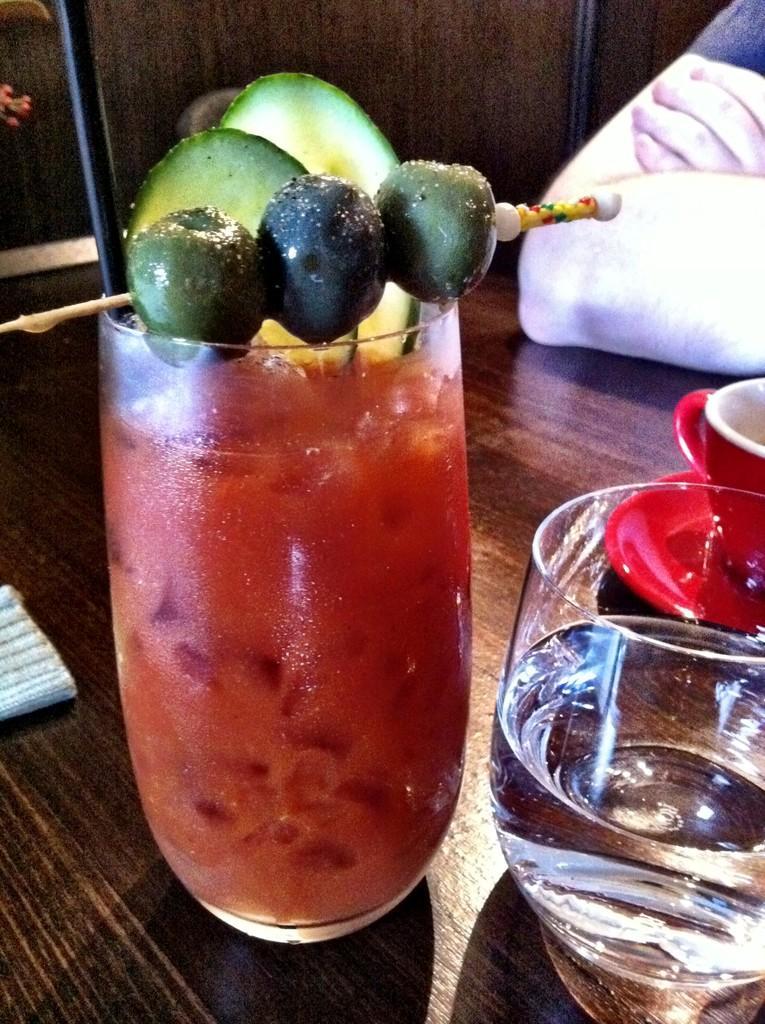Describe this image in one or two sentences. In this image we can see some glasses in which there are some drinks which are on table and in the background of the image there is a person's hand. 